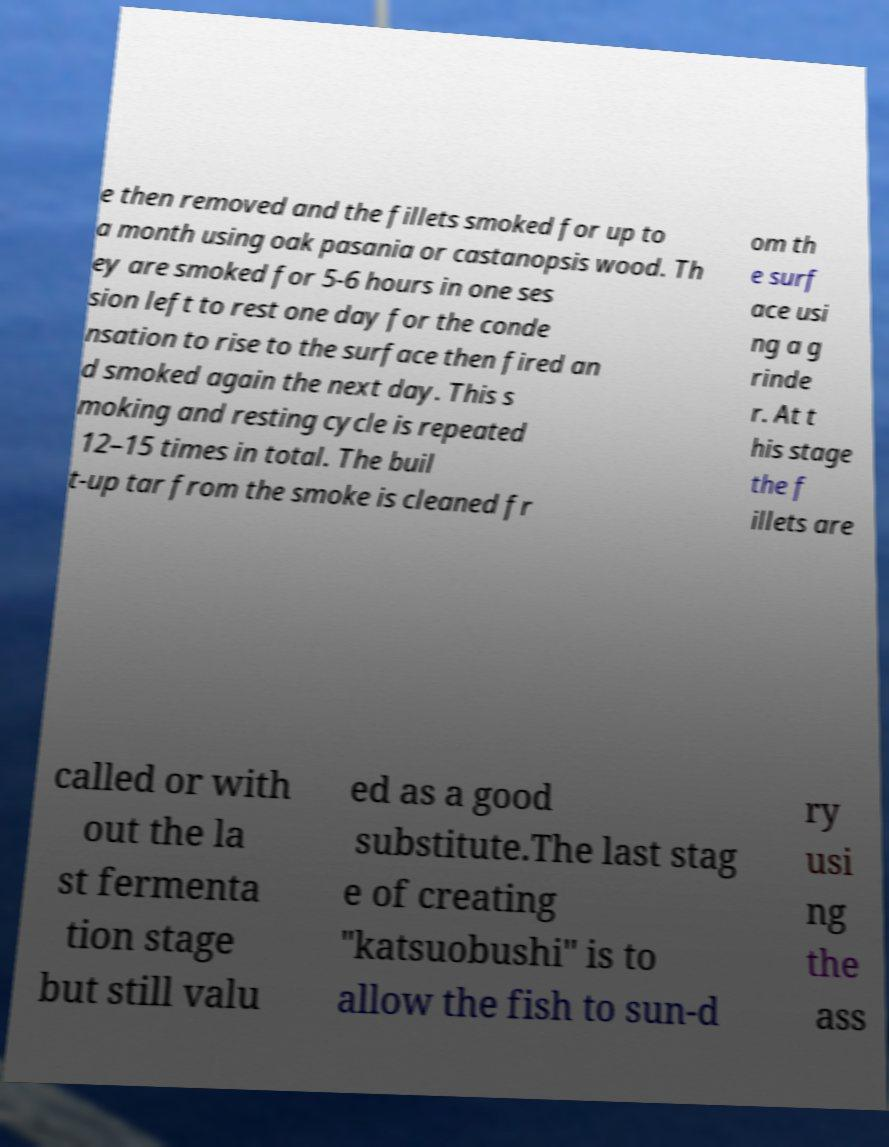Can you accurately transcribe the text from the provided image for me? e then removed and the fillets smoked for up to a month using oak pasania or castanopsis wood. Th ey are smoked for 5-6 hours in one ses sion left to rest one day for the conde nsation to rise to the surface then fired an d smoked again the next day. This s moking and resting cycle is repeated 12–15 times in total. The buil t-up tar from the smoke is cleaned fr om th e surf ace usi ng a g rinde r. At t his stage the f illets are called or with out the la st fermenta tion stage but still valu ed as a good substitute.The last stag e of creating "katsuobushi" is to allow the fish to sun-d ry usi ng the ass 